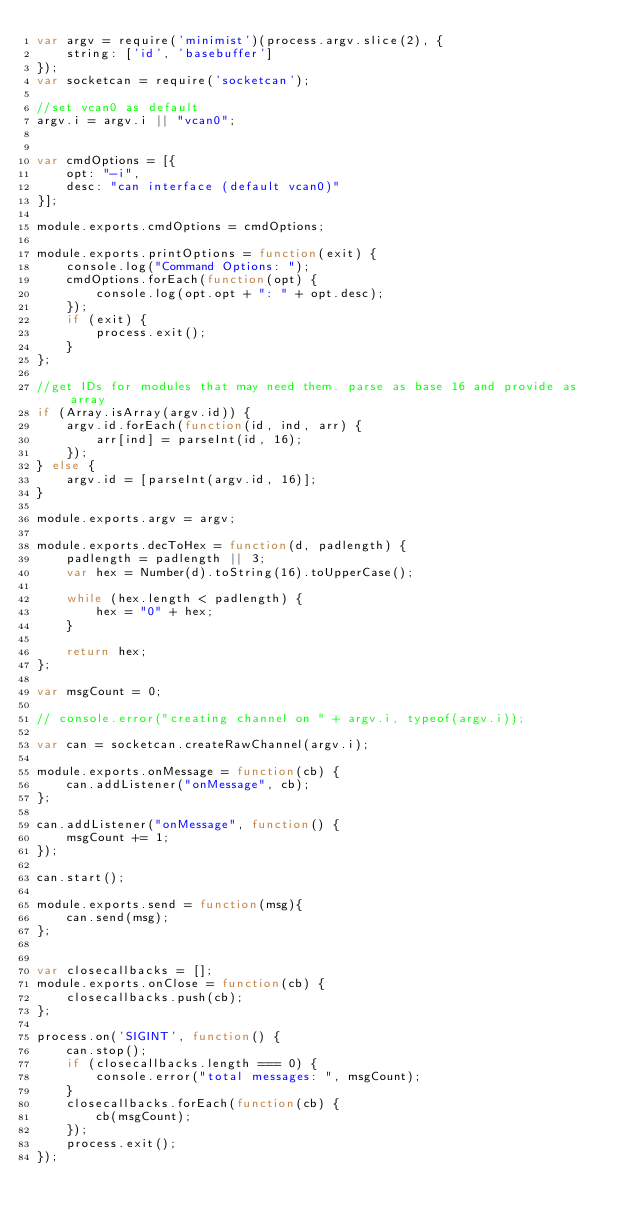Convert code to text. <code><loc_0><loc_0><loc_500><loc_500><_JavaScript_>var argv = require('minimist')(process.argv.slice(2), {
	string: ['id', 'basebuffer']
});
var socketcan = require('socketcan');

//set vcan0 as default
argv.i = argv.i || "vcan0";


var cmdOptions = [{
	opt: "-i",
	desc: "can interface (default vcan0)"
}];

module.exports.cmdOptions = cmdOptions;

module.exports.printOptions = function(exit) {
	console.log("Command Options: ");
	cmdOptions.forEach(function(opt) {
		console.log(opt.opt + ": " + opt.desc);
	});
	if (exit) {
		process.exit();
	}
};

//get IDs for modules that may need them. parse as base 16 and provide as array
if (Array.isArray(argv.id)) {
	argv.id.forEach(function(id, ind, arr) {
		arr[ind] = parseInt(id, 16);
	});
} else {
	argv.id = [parseInt(argv.id, 16)];
}

module.exports.argv = argv;

module.exports.decToHex = function(d, padlength) {
	padlength = padlength || 3;
	var hex = Number(d).toString(16).toUpperCase();

	while (hex.length < padlength) {
		hex = "0" + hex;
	}

	return hex;
};

var msgCount = 0;

// console.error("creating channel on " + argv.i, typeof(argv.i));

var can = socketcan.createRawChannel(argv.i);

module.exports.onMessage = function(cb) {
	can.addListener("onMessage", cb);
};

can.addListener("onMessage", function() {
	msgCount += 1;
});

can.start();

module.exports.send = function(msg){
	can.send(msg);
};


var closecallbacks = [];
module.exports.onClose = function(cb) {
	closecallbacks.push(cb);
};

process.on('SIGINT', function() {
	can.stop();
	if (closecallbacks.length === 0) {
		console.error("total messages: ", msgCount);
	}
	closecallbacks.forEach(function(cb) {
		cb(msgCount);
	});
	process.exit();
});</code> 